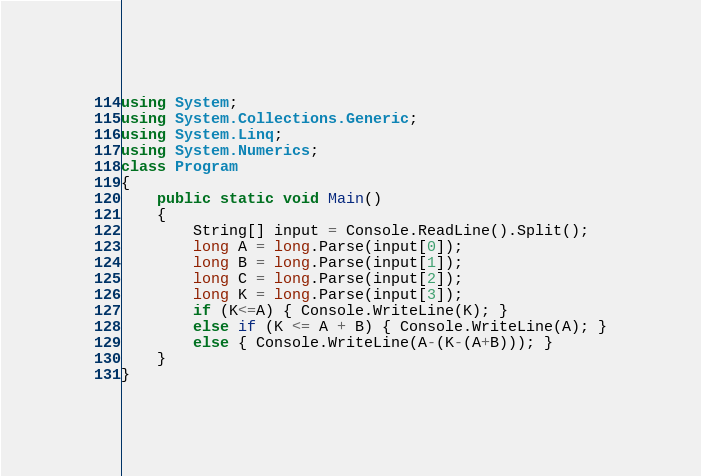Convert code to text. <code><loc_0><loc_0><loc_500><loc_500><_C#_>using System;
using System.Collections.Generic;
using System.Linq;
using System.Numerics;
class Program
{
    public static void Main()
    {
        String[] input = Console.ReadLine().Split();
        long A = long.Parse(input[0]);
        long B = long.Parse(input[1]);
        long C = long.Parse(input[2]);
        long K = long.Parse(input[3]);
        if (K<=A) { Console.WriteLine(K); }
        else if (K <= A + B) { Console.WriteLine(A); }
        else { Console.WriteLine(A-(K-(A+B))); }
    }
}</code> 